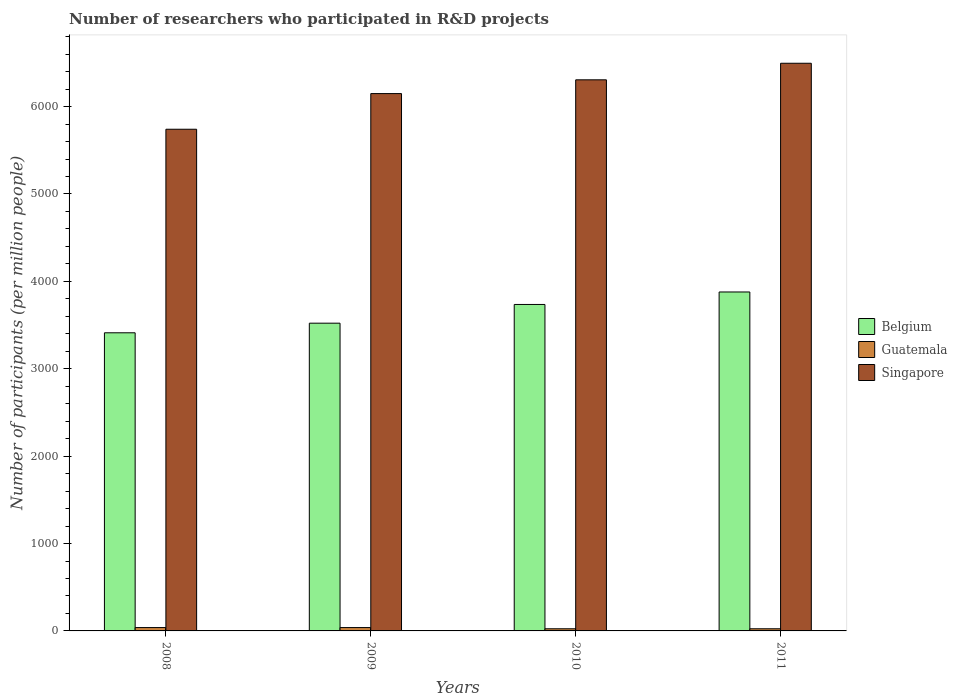Are the number of bars per tick equal to the number of legend labels?
Your answer should be compact. Yes. Are the number of bars on each tick of the X-axis equal?
Ensure brevity in your answer.  Yes. How many bars are there on the 1st tick from the left?
Provide a succinct answer. 3. What is the label of the 1st group of bars from the left?
Offer a very short reply. 2008. In how many cases, is the number of bars for a given year not equal to the number of legend labels?
Ensure brevity in your answer.  0. What is the number of researchers who participated in R&D projects in Belgium in 2010?
Give a very brief answer. 3735.82. Across all years, what is the maximum number of researchers who participated in R&D projects in Singapore?
Your answer should be very brief. 6495.99. Across all years, what is the minimum number of researchers who participated in R&D projects in Singapore?
Offer a very short reply. 5740.84. In which year was the number of researchers who participated in R&D projects in Singapore minimum?
Provide a succinct answer. 2008. What is the total number of researchers who participated in R&D projects in Singapore in the graph?
Make the answer very short. 2.47e+04. What is the difference between the number of researchers who participated in R&D projects in Belgium in 2009 and that in 2010?
Offer a very short reply. -214.17. What is the difference between the number of researchers who participated in R&D projects in Belgium in 2008 and the number of researchers who participated in R&D projects in Singapore in 2010?
Your answer should be very brief. -2894.89. What is the average number of researchers who participated in R&D projects in Guatemala per year?
Your answer should be compact. 31.48. In the year 2009, what is the difference between the number of researchers who participated in R&D projects in Guatemala and number of researchers who participated in R&D projects in Singapore?
Provide a succinct answer. -6110.54. In how many years, is the number of researchers who participated in R&D projects in Singapore greater than 2400?
Your answer should be very brief. 4. What is the ratio of the number of researchers who participated in R&D projects in Belgium in 2008 to that in 2009?
Provide a succinct answer. 0.97. Is the difference between the number of researchers who participated in R&D projects in Guatemala in 2009 and 2011 greater than the difference between the number of researchers who participated in R&D projects in Singapore in 2009 and 2011?
Your answer should be very brief. Yes. What is the difference between the highest and the second highest number of researchers who participated in R&D projects in Belgium?
Your answer should be compact. 142.88. What is the difference between the highest and the lowest number of researchers who participated in R&D projects in Belgium?
Provide a short and direct response. 467.07. Is the sum of the number of researchers who participated in R&D projects in Belgium in 2010 and 2011 greater than the maximum number of researchers who participated in R&D projects in Singapore across all years?
Make the answer very short. Yes. What does the 3rd bar from the left in 2009 represents?
Give a very brief answer. Singapore. What does the 1st bar from the right in 2008 represents?
Offer a terse response. Singapore. Is it the case that in every year, the sum of the number of researchers who participated in R&D projects in Belgium and number of researchers who participated in R&D projects in Singapore is greater than the number of researchers who participated in R&D projects in Guatemala?
Your answer should be very brief. Yes. How many bars are there?
Your response must be concise. 12. Are all the bars in the graph horizontal?
Your answer should be very brief. No. How many years are there in the graph?
Provide a short and direct response. 4. How are the legend labels stacked?
Offer a very short reply. Vertical. What is the title of the graph?
Ensure brevity in your answer.  Number of researchers who participated in R&D projects. Does "American Samoa" appear as one of the legend labels in the graph?
Give a very brief answer. No. What is the label or title of the Y-axis?
Your answer should be compact. Number of participants (per million people). What is the Number of participants (per million people) in Belgium in 2008?
Provide a succinct answer. 3411.63. What is the Number of participants (per million people) of Guatemala in 2008?
Offer a very short reply. 38.28. What is the Number of participants (per million people) of Singapore in 2008?
Your response must be concise. 5740.84. What is the Number of participants (per million people) of Belgium in 2009?
Provide a succinct answer. 3521.66. What is the Number of participants (per million people) in Guatemala in 2009?
Offer a terse response. 38.42. What is the Number of participants (per million people) of Singapore in 2009?
Keep it short and to the point. 6148.96. What is the Number of participants (per million people) of Belgium in 2010?
Keep it short and to the point. 3735.82. What is the Number of participants (per million people) in Guatemala in 2010?
Make the answer very short. 24.64. What is the Number of participants (per million people) in Singapore in 2010?
Ensure brevity in your answer.  6306.52. What is the Number of participants (per million people) in Belgium in 2011?
Provide a succinct answer. 3878.7. What is the Number of participants (per million people) in Guatemala in 2011?
Ensure brevity in your answer.  24.59. What is the Number of participants (per million people) in Singapore in 2011?
Offer a very short reply. 6495.99. Across all years, what is the maximum Number of participants (per million people) in Belgium?
Provide a succinct answer. 3878.7. Across all years, what is the maximum Number of participants (per million people) in Guatemala?
Give a very brief answer. 38.42. Across all years, what is the maximum Number of participants (per million people) of Singapore?
Ensure brevity in your answer.  6495.99. Across all years, what is the minimum Number of participants (per million people) in Belgium?
Provide a short and direct response. 3411.63. Across all years, what is the minimum Number of participants (per million people) in Guatemala?
Offer a terse response. 24.59. Across all years, what is the minimum Number of participants (per million people) in Singapore?
Your answer should be very brief. 5740.84. What is the total Number of participants (per million people) of Belgium in the graph?
Make the answer very short. 1.45e+04. What is the total Number of participants (per million people) in Guatemala in the graph?
Ensure brevity in your answer.  125.93. What is the total Number of participants (per million people) of Singapore in the graph?
Offer a very short reply. 2.47e+04. What is the difference between the Number of participants (per million people) of Belgium in 2008 and that in 2009?
Your answer should be very brief. -110.03. What is the difference between the Number of participants (per million people) of Guatemala in 2008 and that in 2009?
Your response must be concise. -0.14. What is the difference between the Number of participants (per million people) of Singapore in 2008 and that in 2009?
Provide a short and direct response. -408.12. What is the difference between the Number of participants (per million people) in Belgium in 2008 and that in 2010?
Offer a very short reply. -324.2. What is the difference between the Number of participants (per million people) in Guatemala in 2008 and that in 2010?
Offer a very short reply. 13.64. What is the difference between the Number of participants (per million people) in Singapore in 2008 and that in 2010?
Your answer should be very brief. -565.68. What is the difference between the Number of participants (per million people) in Belgium in 2008 and that in 2011?
Offer a very short reply. -467.07. What is the difference between the Number of participants (per million people) in Guatemala in 2008 and that in 2011?
Make the answer very short. 13.69. What is the difference between the Number of participants (per million people) in Singapore in 2008 and that in 2011?
Ensure brevity in your answer.  -755.15. What is the difference between the Number of participants (per million people) in Belgium in 2009 and that in 2010?
Your answer should be very brief. -214.17. What is the difference between the Number of participants (per million people) of Guatemala in 2009 and that in 2010?
Provide a succinct answer. 13.78. What is the difference between the Number of participants (per million people) in Singapore in 2009 and that in 2010?
Make the answer very short. -157.56. What is the difference between the Number of participants (per million people) of Belgium in 2009 and that in 2011?
Your answer should be very brief. -357.04. What is the difference between the Number of participants (per million people) of Guatemala in 2009 and that in 2011?
Ensure brevity in your answer.  13.84. What is the difference between the Number of participants (per million people) in Singapore in 2009 and that in 2011?
Provide a short and direct response. -347.03. What is the difference between the Number of participants (per million people) of Belgium in 2010 and that in 2011?
Your answer should be compact. -142.88. What is the difference between the Number of participants (per million people) of Guatemala in 2010 and that in 2011?
Offer a very short reply. 0.05. What is the difference between the Number of participants (per million people) of Singapore in 2010 and that in 2011?
Ensure brevity in your answer.  -189.47. What is the difference between the Number of participants (per million people) of Belgium in 2008 and the Number of participants (per million people) of Guatemala in 2009?
Your response must be concise. 3373.2. What is the difference between the Number of participants (per million people) in Belgium in 2008 and the Number of participants (per million people) in Singapore in 2009?
Your response must be concise. -2737.33. What is the difference between the Number of participants (per million people) of Guatemala in 2008 and the Number of participants (per million people) of Singapore in 2009?
Offer a very short reply. -6110.68. What is the difference between the Number of participants (per million people) in Belgium in 2008 and the Number of participants (per million people) in Guatemala in 2010?
Your answer should be very brief. 3386.99. What is the difference between the Number of participants (per million people) in Belgium in 2008 and the Number of participants (per million people) in Singapore in 2010?
Keep it short and to the point. -2894.89. What is the difference between the Number of participants (per million people) of Guatemala in 2008 and the Number of participants (per million people) of Singapore in 2010?
Your answer should be very brief. -6268.24. What is the difference between the Number of participants (per million people) in Belgium in 2008 and the Number of participants (per million people) in Guatemala in 2011?
Your response must be concise. 3387.04. What is the difference between the Number of participants (per million people) in Belgium in 2008 and the Number of participants (per million people) in Singapore in 2011?
Your answer should be very brief. -3084.36. What is the difference between the Number of participants (per million people) of Guatemala in 2008 and the Number of participants (per million people) of Singapore in 2011?
Make the answer very short. -6457.71. What is the difference between the Number of participants (per million people) in Belgium in 2009 and the Number of participants (per million people) in Guatemala in 2010?
Keep it short and to the point. 3497.02. What is the difference between the Number of participants (per million people) of Belgium in 2009 and the Number of participants (per million people) of Singapore in 2010?
Offer a very short reply. -2784.86. What is the difference between the Number of participants (per million people) in Guatemala in 2009 and the Number of participants (per million people) in Singapore in 2010?
Provide a succinct answer. -6268.1. What is the difference between the Number of participants (per million people) in Belgium in 2009 and the Number of participants (per million people) in Guatemala in 2011?
Your answer should be very brief. 3497.07. What is the difference between the Number of participants (per million people) in Belgium in 2009 and the Number of participants (per million people) in Singapore in 2011?
Give a very brief answer. -2974.33. What is the difference between the Number of participants (per million people) of Guatemala in 2009 and the Number of participants (per million people) of Singapore in 2011?
Your answer should be very brief. -6457.56. What is the difference between the Number of participants (per million people) in Belgium in 2010 and the Number of participants (per million people) in Guatemala in 2011?
Your response must be concise. 3711.24. What is the difference between the Number of participants (per million people) of Belgium in 2010 and the Number of participants (per million people) of Singapore in 2011?
Keep it short and to the point. -2760.16. What is the difference between the Number of participants (per million people) of Guatemala in 2010 and the Number of participants (per million people) of Singapore in 2011?
Your answer should be very brief. -6471.35. What is the average Number of participants (per million people) of Belgium per year?
Ensure brevity in your answer.  3636.95. What is the average Number of participants (per million people) in Guatemala per year?
Give a very brief answer. 31.48. What is the average Number of participants (per million people) of Singapore per year?
Give a very brief answer. 6173.08. In the year 2008, what is the difference between the Number of participants (per million people) of Belgium and Number of participants (per million people) of Guatemala?
Provide a short and direct response. 3373.35. In the year 2008, what is the difference between the Number of participants (per million people) in Belgium and Number of participants (per million people) in Singapore?
Provide a succinct answer. -2329.21. In the year 2008, what is the difference between the Number of participants (per million people) of Guatemala and Number of participants (per million people) of Singapore?
Your answer should be compact. -5702.56. In the year 2009, what is the difference between the Number of participants (per million people) of Belgium and Number of participants (per million people) of Guatemala?
Provide a succinct answer. 3483.23. In the year 2009, what is the difference between the Number of participants (per million people) in Belgium and Number of participants (per million people) in Singapore?
Ensure brevity in your answer.  -2627.31. In the year 2009, what is the difference between the Number of participants (per million people) of Guatemala and Number of participants (per million people) of Singapore?
Offer a terse response. -6110.54. In the year 2010, what is the difference between the Number of participants (per million people) in Belgium and Number of participants (per million people) in Guatemala?
Offer a very short reply. 3711.18. In the year 2010, what is the difference between the Number of participants (per million people) of Belgium and Number of participants (per million people) of Singapore?
Keep it short and to the point. -2570.7. In the year 2010, what is the difference between the Number of participants (per million people) of Guatemala and Number of participants (per million people) of Singapore?
Provide a short and direct response. -6281.88. In the year 2011, what is the difference between the Number of participants (per million people) of Belgium and Number of participants (per million people) of Guatemala?
Provide a short and direct response. 3854.11. In the year 2011, what is the difference between the Number of participants (per million people) in Belgium and Number of participants (per million people) in Singapore?
Provide a short and direct response. -2617.29. In the year 2011, what is the difference between the Number of participants (per million people) in Guatemala and Number of participants (per million people) in Singapore?
Offer a very short reply. -6471.4. What is the ratio of the Number of participants (per million people) of Belgium in 2008 to that in 2009?
Provide a short and direct response. 0.97. What is the ratio of the Number of participants (per million people) of Singapore in 2008 to that in 2009?
Give a very brief answer. 0.93. What is the ratio of the Number of participants (per million people) in Belgium in 2008 to that in 2010?
Offer a very short reply. 0.91. What is the ratio of the Number of participants (per million people) of Guatemala in 2008 to that in 2010?
Your answer should be very brief. 1.55. What is the ratio of the Number of participants (per million people) of Singapore in 2008 to that in 2010?
Your response must be concise. 0.91. What is the ratio of the Number of participants (per million people) in Belgium in 2008 to that in 2011?
Offer a very short reply. 0.88. What is the ratio of the Number of participants (per million people) in Guatemala in 2008 to that in 2011?
Your answer should be compact. 1.56. What is the ratio of the Number of participants (per million people) in Singapore in 2008 to that in 2011?
Provide a short and direct response. 0.88. What is the ratio of the Number of participants (per million people) in Belgium in 2009 to that in 2010?
Your answer should be very brief. 0.94. What is the ratio of the Number of participants (per million people) in Guatemala in 2009 to that in 2010?
Offer a very short reply. 1.56. What is the ratio of the Number of participants (per million people) of Singapore in 2009 to that in 2010?
Keep it short and to the point. 0.97. What is the ratio of the Number of participants (per million people) in Belgium in 2009 to that in 2011?
Offer a very short reply. 0.91. What is the ratio of the Number of participants (per million people) of Guatemala in 2009 to that in 2011?
Offer a very short reply. 1.56. What is the ratio of the Number of participants (per million people) of Singapore in 2009 to that in 2011?
Ensure brevity in your answer.  0.95. What is the ratio of the Number of participants (per million people) of Belgium in 2010 to that in 2011?
Ensure brevity in your answer.  0.96. What is the ratio of the Number of participants (per million people) in Guatemala in 2010 to that in 2011?
Offer a very short reply. 1. What is the ratio of the Number of participants (per million people) in Singapore in 2010 to that in 2011?
Your answer should be compact. 0.97. What is the difference between the highest and the second highest Number of participants (per million people) in Belgium?
Give a very brief answer. 142.88. What is the difference between the highest and the second highest Number of participants (per million people) of Guatemala?
Give a very brief answer. 0.14. What is the difference between the highest and the second highest Number of participants (per million people) in Singapore?
Keep it short and to the point. 189.47. What is the difference between the highest and the lowest Number of participants (per million people) of Belgium?
Your answer should be compact. 467.07. What is the difference between the highest and the lowest Number of participants (per million people) of Guatemala?
Make the answer very short. 13.84. What is the difference between the highest and the lowest Number of participants (per million people) in Singapore?
Provide a short and direct response. 755.15. 